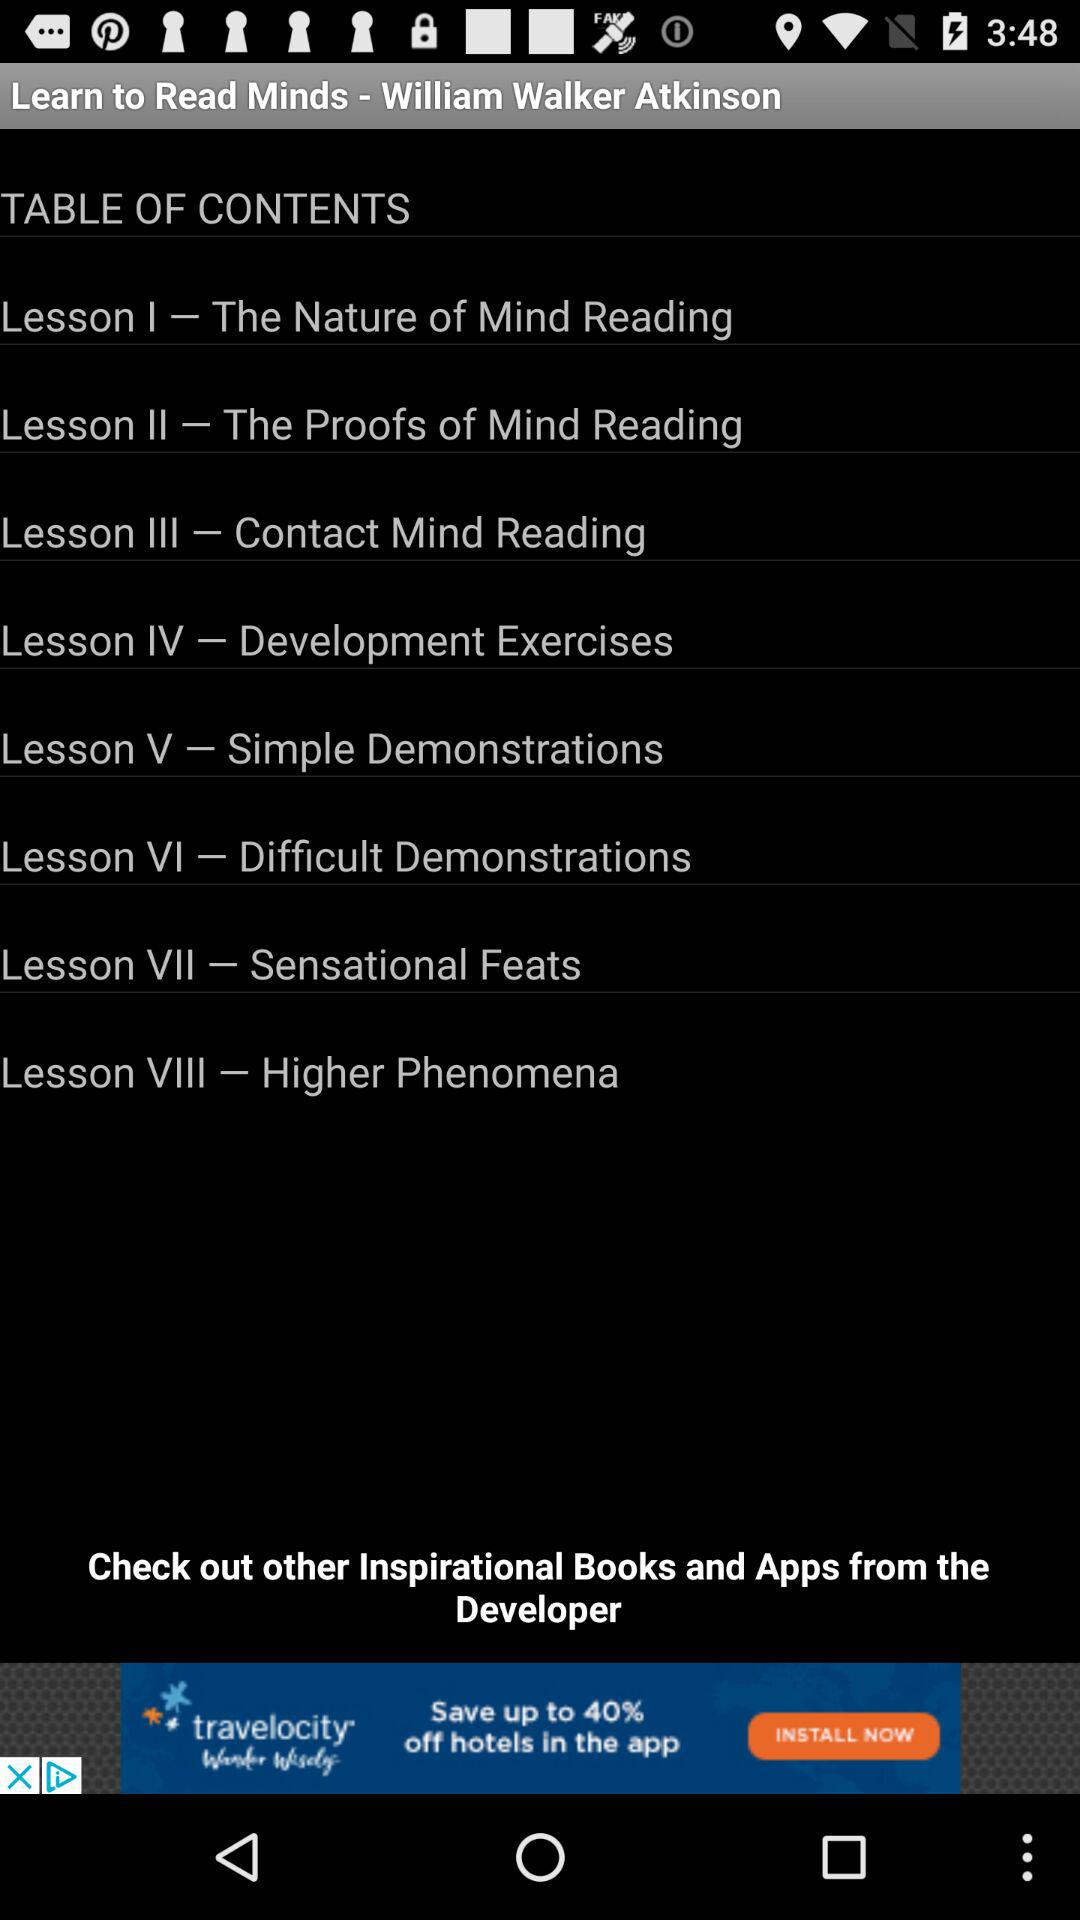How many lessons are in this book?
Answer the question using a single word or phrase. 8 